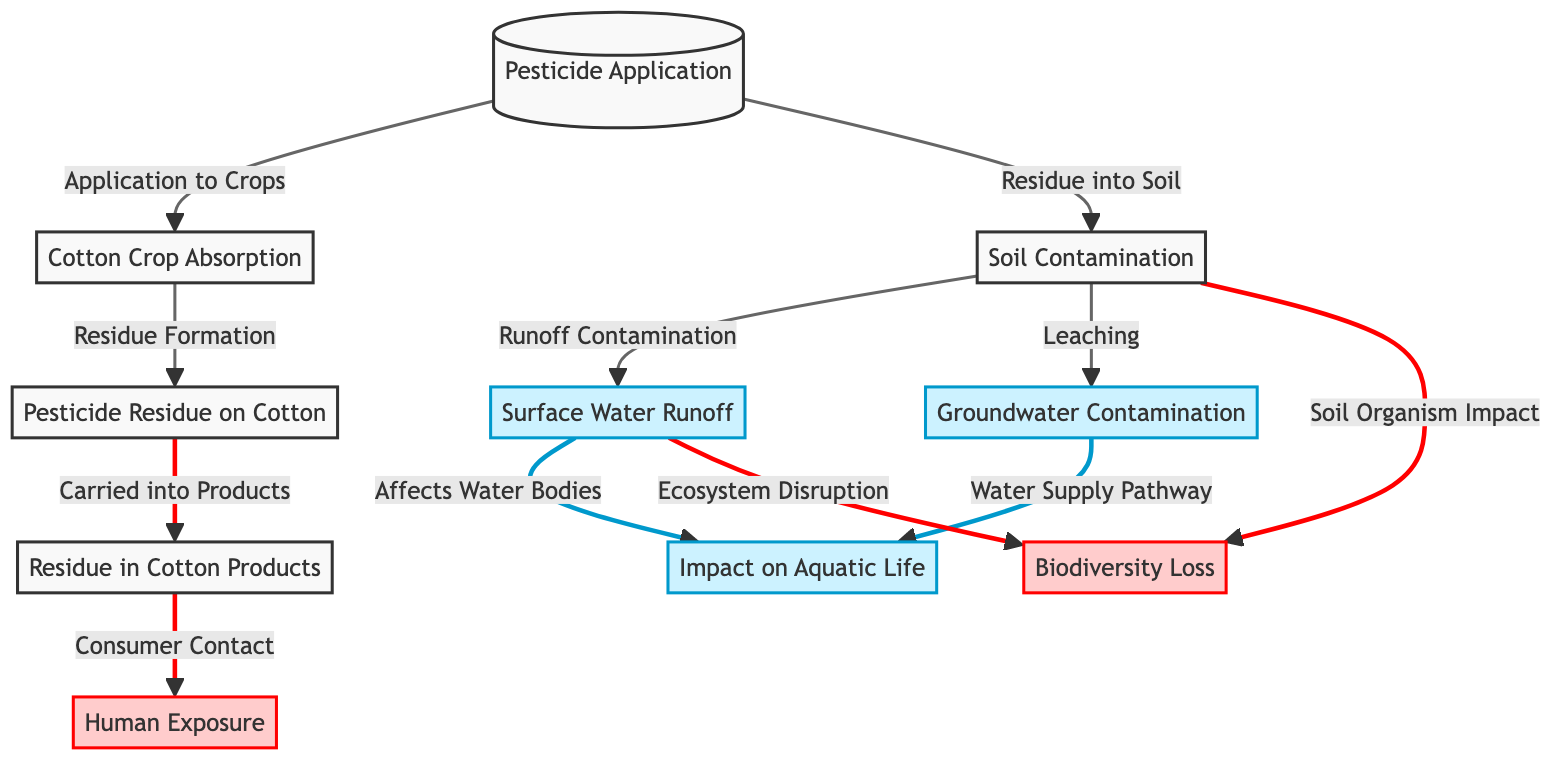What is the first step in the lifecycle of pesticides in conventional cotton farming? The diagram starts with the "Pesticide Application," which is the initial action taken in this lifecycle.
Answer: Pesticide Application How many impacts are identified in the diagram? The diagram lists three impacts related to the pesticide lifecycle, each represented as a node.
Answer: 3 What is the relationship between "Soil Contamination" and "Surface Water Runoff"? The diagram shows that "Soil Contamination" leads to "Surface Water Runoff" through the "Runoff Contamination" pathway.
Answer: Runoff Contamination What happens to pesticide residue after it is absorbed by the cotton crop? After absorption by the cotton, pesticide residue is formed, leading to "Pesticide Residue on Cotton."
Answer: Pesticide Residue on Cotton Which impact is associated with consumer contact? The node "Human Exposure" is directly linked to the "Residue in Cotton Products," indicating this impact.
Answer: Human Exposure What pathways lead to "Impact on Aquatic Life"? The diagram indicates that both "Surface Water Runoff" and "Groundwater Contamination" can affect water bodies, impacting aquatic life.
Answer: Surface Water Runoff and Groundwater Contamination Which node represents the direct consequence of pesticide being carried into cotton products? The node "Residue in Cotton Products" is the direct result of pesticide residue being transported into consumer products.
Answer: Residue in Cotton Products What does "Soil Organism Impact" affect according to the diagram? This node indicates that soil contamination resulting from pesticide application can lead to "Biodiversity Loss" due to its impact on soil organisms.
Answer: Biodiversity Loss 